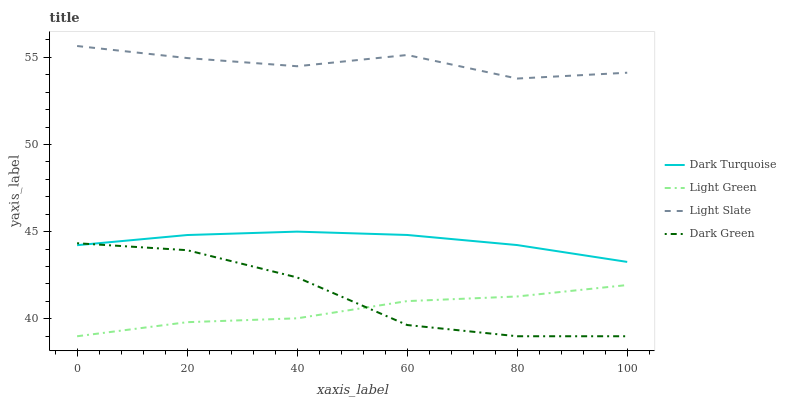Does Light Green have the minimum area under the curve?
Answer yes or no. Yes. Does Light Slate have the maximum area under the curve?
Answer yes or no. Yes. Does Dark Turquoise have the minimum area under the curve?
Answer yes or no. No. Does Dark Turquoise have the maximum area under the curve?
Answer yes or no. No. Is Dark Turquoise the smoothest?
Answer yes or no. Yes. Is Dark Green the roughest?
Answer yes or no. Yes. Is Light Green the smoothest?
Answer yes or no. No. Is Light Green the roughest?
Answer yes or no. No. Does Light Green have the lowest value?
Answer yes or no. Yes. Does Dark Turquoise have the lowest value?
Answer yes or no. No. Does Light Slate have the highest value?
Answer yes or no. Yes. Does Dark Turquoise have the highest value?
Answer yes or no. No. Is Light Green less than Light Slate?
Answer yes or no. Yes. Is Light Slate greater than Light Green?
Answer yes or no. Yes. Does Light Green intersect Dark Green?
Answer yes or no. Yes. Is Light Green less than Dark Green?
Answer yes or no. No. Is Light Green greater than Dark Green?
Answer yes or no. No. Does Light Green intersect Light Slate?
Answer yes or no. No. 